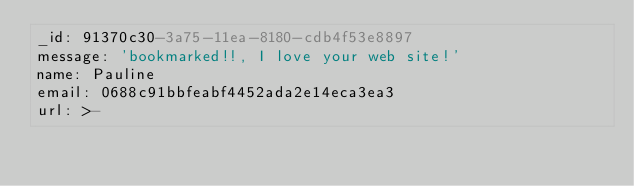<code> <loc_0><loc_0><loc_500><loc_500><_YAML_>_id: 91370c30-3a75-11ea-8180-cdb4f53e8897
message: 'bookmarked!!, I love your web site!'
name: Pauline
email: 0688c91bbfeabf4452ada2e14eca3ea3
url: >-</code> 